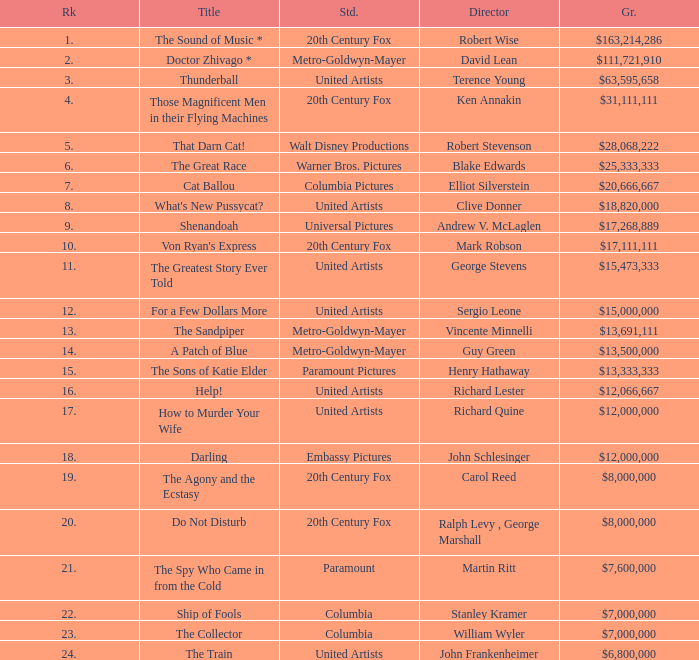Parse the table in full. {'header': ['Rk', 'Title', 'Std.', 'Director', 'Gr.'], 'rows': [['1.', 'The Sound of Music *', '20th Century Fox', 'Robert Wise', '$163,214,286'], ['2.', 'Doctor Zhivago *', 'Metro-Goldwyn-Mayer', 'David Lean', '$111,721,910'], ['3.', 'Thunderball', 'United Artists', 'Terence Young', '$63,595,658'], ['4.', 'Those Magnificent Men in their Flying Machines', '20th Century Fox', 'Ken Annakin', '$31,111,111'], ['5.', 'That Darn Cat!', 'Walt Disney Productions', 'Robert Stevenson', '$28,068,222'], ['6.', 'The Great Race', 'Warner Bros. Pictures', 'Blake Edwards', '$25,333,333'], ['7.', 'Cat Ballou', 'Columbia Pictures', 'Elliot Silverstein', '$20,666,667'], ['8.', "What's New Pussycat?", 'United Artists', 'Clive Donner', '$18,820,000'], ['9.', 'Shenandoah', 'Universal Pictures', 'Andrew V. McLaglen', '$17,268,889'], ['10.', "Von Ryan's Express", '20th Century Fox', 'Mark Robson', '$17,111,111'], ['11.', 'The Greatest Story Ever Told', 'United Artists', 'George Stevens', '$15,473,333'], ['12.', 'For a Few Dollars More', 'United Artists', 'Sergio Leone', '$15,000,000'], ['13.', 'The Sandpiper', 'Metro-Goldwyn-Mayer', 'Vincente Minnelli', '$13,691,111'], ['14.', 'A Patch of Blue', 'Metro-Goldwyn-Mayer', 'Guy Green', '$13,500,000'], ['15.', 'The Sons of Katie Elder', 'Paramount Pictures', 'Henry Hathaway', '$13,333,333'], ['16.', 'Help!', 'United Artists', 'Richard Lester', '$12,066,667'], ['17.', 'How to Murder Your Wife', 'United Artists', 'Richard Quine', '$12,000,000'], ['18.', 'Darling', 'Embassy Pictures', 'John Schlesinger', '$12,000,000'], ['19.', 'The Agony and the Ecstasy', '20th Century Fox', 'Carol Reed', '$8,000,000'], ['20.', 'Do Not Disturb', '20th Century Fox', 'Ralph Levy , George Marshall', '$8,000,000'], ['21.', 'The Spy Who Came in from the Cold', 'Paramount', 'Martin Ritt', '$7,600,000'], ['22.', 'Ship of Fools', 'Columbia', 'Stanley Kramer', '$7,000,000'], ['23.', 'The Collector', 'Columbia', 'William Wyler', '$7,000,000'], ['24.', 'The Train', 'United Artists', 'John Frankenheimer', '$6,800,000']]} What is the heading, when the studio is "embassy pictures"? Darling. 